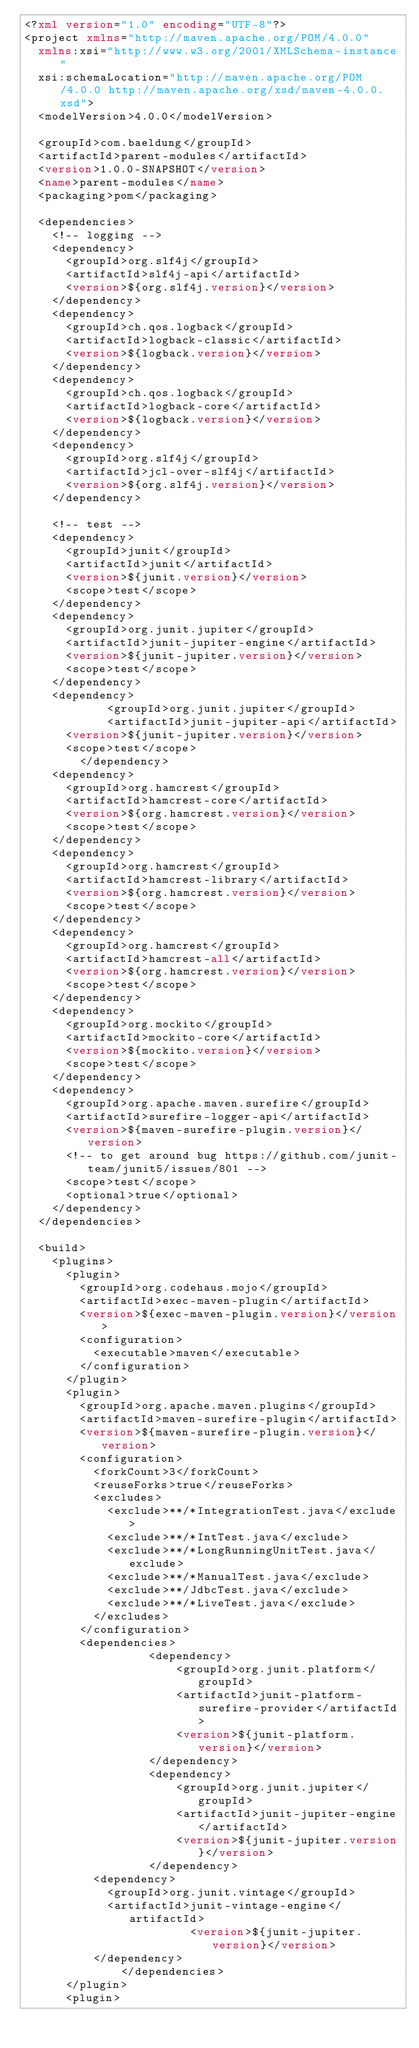<code> <loc_0><loc_0><loc_500><loc_500><_XML_><?xml version="1.0" encoding="UTF-8"?>
<project xmlns="http://maven.apache.org/POM/4.0.0"
	xmlns:xsi="http://www.w3.org/2001/XMLSchema-instance"
	xsi:schemaLocation="http://maven.apache.org/POM/4.0.0 http://maven.apache.org/xsd/maven-4.0.0.xsd">
	<modelVersion>4.0.0</modelVersion>

	<groupId>com.baeldung</groupId>
	<artifactId>parent-modules</artifactId>
	<version>1.0.0-SNAPSHOT</version>
	<name>parent-modules</name>
	<packaging>pom</packaging>

	<dependencies>
		<!-- logging -->
		<dependency>
			<groupId>org.slf4j</groupId>
			<artifactId>slf4j-api</artifactId>
			<version>${org.slf4j.version}</version>
		</dependency>
		<dependency>
			<groupId>ch.qos.logback</groupId>
			<artifactId>logback-classic</artifactId>
			<version>${logback.version}</version>
		</dependency>
		<dependency>
			<groupId>ch.qos.logback</groupId>
			<artifactId>logback-core</artifactId>
			<version>${logback.version}</version>
		</dependency>
		<dependency>
			<groupId>org.slf4j</groupId>
			<artifactId>jcl-over-slf4j</artifactId>
			<version>${org.slf4j.version}</version>
		</dependency>

		<!-- test -->
		<dependency>
			<groupId>junit</groupId>
			<artifactId>junit</artifactId>
			<version>${junit.version}</version>
			<scope>test</scope>
		</dependency>
		<dependency>
			<groupId>org.junit.jupiter</groupId>
			<artifactId>junit-jupiter-engine</artifactId>
			<version>${junit-jupiter.version}</version>
			<scope>test</scope>
		</dependency>
		<dependency>
            <groupId>org.junit.jupiter</groupId>
            <artifactId>junit-jupiter-api</artifactId>
			<version>${junit-jupiter.version}</version>
			<scope>test</scope>
        </dependency>
		<dependency>
			<groupId>org.hamcrest</groupId>
			<artifactId>hamcrest-core</artifactId>
			<version>${org.hamcrest.version}</version>
			<scope>test</scope>
		</dependency>
		<dependency>
			<groupId>org.hamcrest</groupId>
			<artifactId>hamcrest-library</artifactId>
			<version>${org.hamcrest.version}</version>
			<scope>test</scope>
		</dependency>
		<dependency>
			<groupId>org.hamcrest</groupId>
			<artifactId>hamcrest-all</artifactId>
			<version>${org.hamcrest.version}</version>
			<scope>test</scope>
		</dependency>
		<dependency>
			<groupId>org.mockito</groupId>
			<artifactId>mockito-core</artifactId>
			<version>${mockito.version}</version>
			<scope>test</scope>
		</dependency>
		<dependency>
			<groupId>org.apache.maven.surefire</groupId>
			<artifactId>surefire-logger-api</artifactId>
			<version>${maven-surefire-plugin.version}</version>
			<!-- to get around bug https://github.com/junit-team/junit5/issues/801 -->
			<scope>test</scope>
			<optional>true</optional>
		</dependency>
	</dependencies>

	<build>
		<plugins>
			<plugin>
				<groupId>org.codehaus.mojo</groupId>
				<artifactId>exec-maven-plugin</artifactId>
				<version>${exec-maven-plugin.version}</version>
				<configuration>
					<executable>maven</executable>
				</configuration>
			</plugin>
			<plugin>
				<groupId>org.apache.maven.plugins</groupId>
				<artifactId>maven-surefire-plugin</artifactId>
				<version>${maven-surefire-plugin.version}</version>
				<configuration>
					<forkCount>3</forkCount>
					<reuseForks>true</reuseForks>
					<excludes>
						<exclude>**/*IntegrationTest.java</exclude>
						<exclude>**/*IntTest.java</exclude>
						<exclude>**/*LongRunningUnitTest.java</exclude>
						<exclude>**/*ManualTest.java</exclude>
						<exclude>**/JdbcTest.java</exclude>
						<exclude>**/*LiveTest.java</exclude>
					</excludes>
				</configuration>
				<dependencies>
	                <dependency>
	                    <groupId>org.junit.platform</groupId>
	                    <artifactId>junit-platform-surefire-provider</artifactId>
	                    <version>${junit-platform.version}</version>
	                </dependency>
	                <dependency>
	                    <groupId>org.junit.jupiter</groupId>
	                    <artifactId>junit-jupiter-engine</artifactId>
	                    <version>${junit-jupiter.version}</version>
	                </dependency>
					<dependency>
						<groupId>org.junit.vintage</groupId>
						<artifactId>junit-vintage-engine</artifactId>
  	                    <version>${junit-jupiter.version}</version>
					</dependency>
            	</dependencies>
			</plugin>
			<plugin></code> 